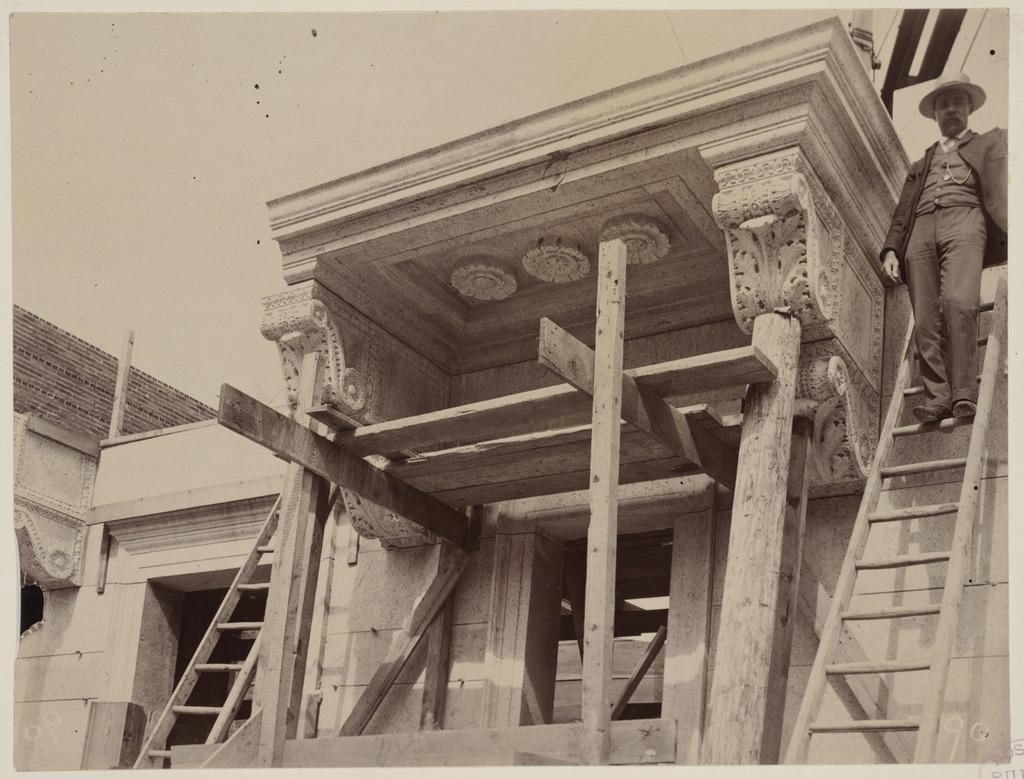Could you give a brief overview of what you see in this image? This is a black and white picture, there is a man standing on a ladder of a building. 